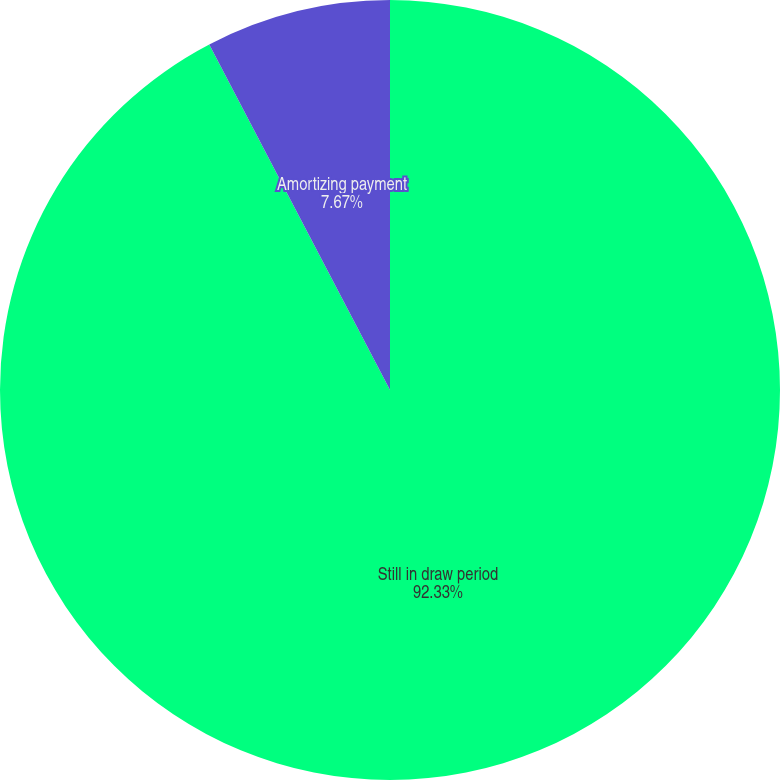Convert chart. <chart><loc_0><loc_0><loc_500><loc_500><pie_chart><fcel>Still in draw period<fcel>Amortizing payment<nl><fcel>92.33%<fcel>7.67%<nl></chart> 